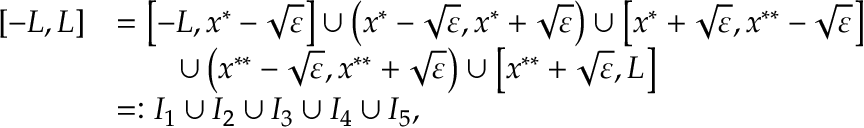Convert formula to latex. <formula><loc_0><loc_0><loc_500><loc_500>\begin{array} { r } { \begin{array} { r l } { [ - L , L ] } & { = \left [ - L , x ^ { * } - \sqrt { \varepsilon } \right ] \cup \left ( x ^ { * } - \sqrt { \varepsilon } , x ^ { * } + \sqrt { \varepsilon } \right ) \cup \left [ x ^ { * } + \sqrt { \varepsilon } , x ^ { * * } - \sqrt { \varepsilon } \right ] } \\ & { \quad \cup \left ( x ^ { * * } - \sqrt { \varepsilon } , x ^ { * * } + \sqrt { \varepsilon } \right ) \cup \left [ x ^ { * * } + \sqrt { \varepsilon } , L \right ] } \\ & { = \colon I _ { 1 } \cup I _ { 2 } \cup I _ { 3 } \cup I _ { 4 } \cup I _ { 5 } , } \end{array} } \end{array}</formula> 